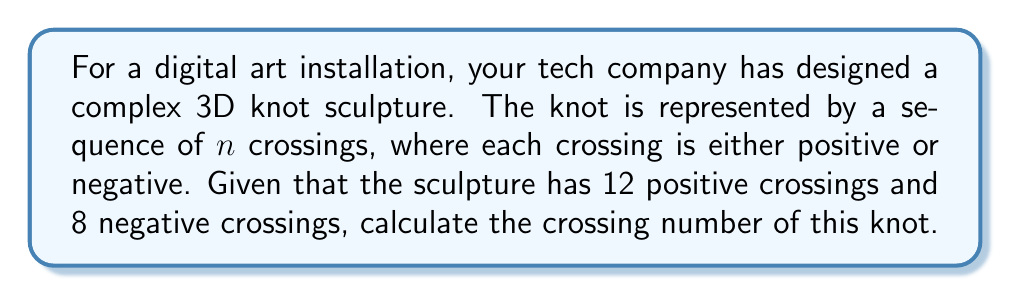Solve this math problem. To calculate the crossing number of a knot, we need to follow these steps:

1. Understand the concept of crossing number:
   The crossing number of a knot is the minimum number of crossings that occur in any projection of the knot onto a plane.

2. Identify the total number of crossings:
   In this case, we have:
   Positive crossings: 12
   Negative crossings: 8
   Total crossings = Positive crossings + Negative crossings
   $n = 12 + 8 = 20$

3. Consider the definition of crossing number:
   The crossing number is always less than or equal to the total number of crossings in any given projection. This is because the minimum number of crossings might be achieved through a different projection or by simplifying the knot.

4. Determine the crossing number:
   In this problem, we are not given any information about potential simplifications or alternative projections. Therefore, we assume that the given representation is the simplest form of the knot.

5. Conclude:
   The crossing number of the knot is equal to the total number of crossings, which is 20.

It's important to note that in real-world applications, determining if a given projection represents the minimal crossing number can be a complex problem in itself, often requiring advanced techniques in knot theory.
Answer: 20 